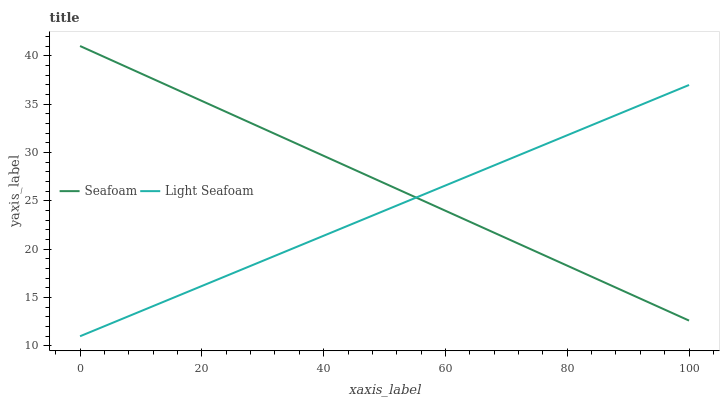Does Light Seafoam have the minimum area under the curve?
Answer yes or no. Yes. Does Seafoam have the maximum area under the curve?
Answer yes or no. Yes. Does Seafoam have the minimum area under the curve?
Answer yes or no. No. Is Light Seafoam the smoothest?
Answer yes or no. Yes. Is Seafoam the roughest?
Answer yes or no. Yes. Is Seafoam the smoothest?
Answer yes or no. No. Does Light Seafoam have the lowest value?
Answer yes or no. Yes. Does Seafoam have the lowest value?
Answer yes or no. No. Does Seafoam have the highest value?
Answer yes or no. Yes. Does Light Seafoam intersect Seafoam?
Answer yes or no. Yes. Is Light Seafoam less than Seafoam?
Answer yes or no. No. Is Light Seafoam greater than Seafoam?
Answer yes or no. No. 